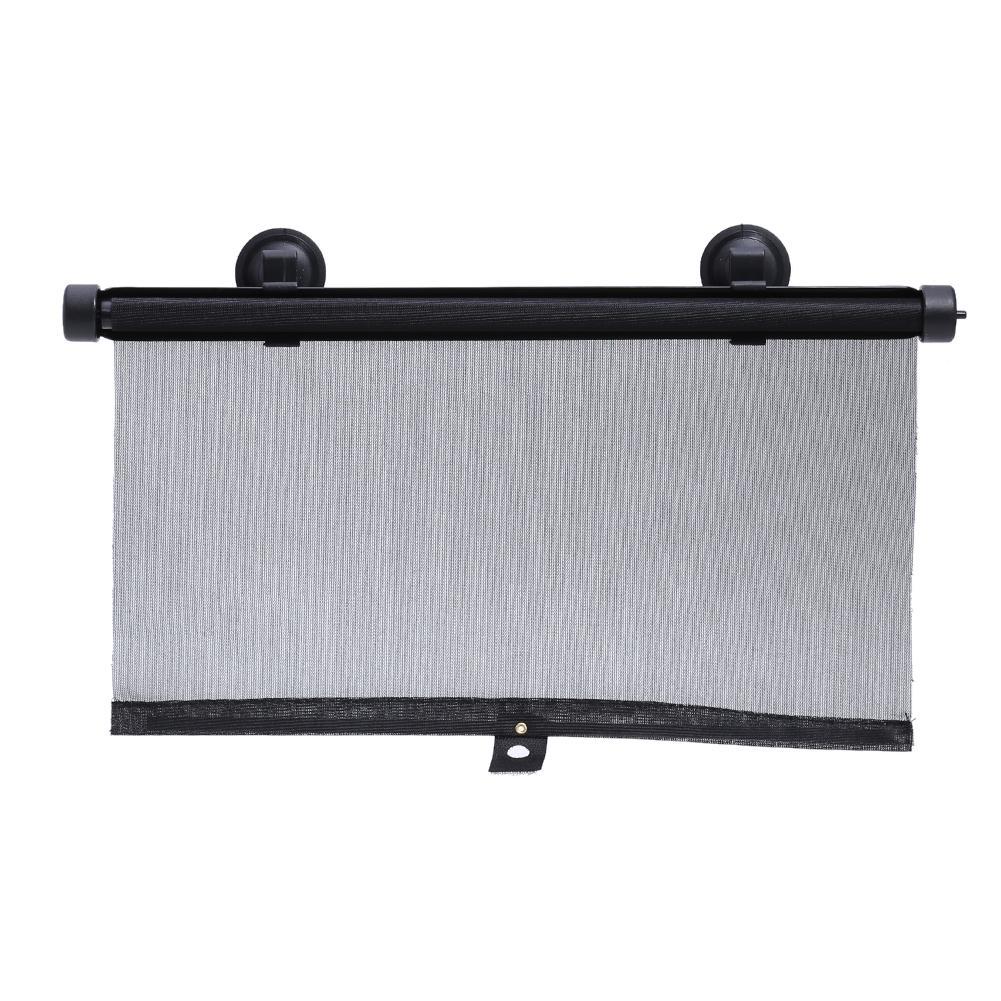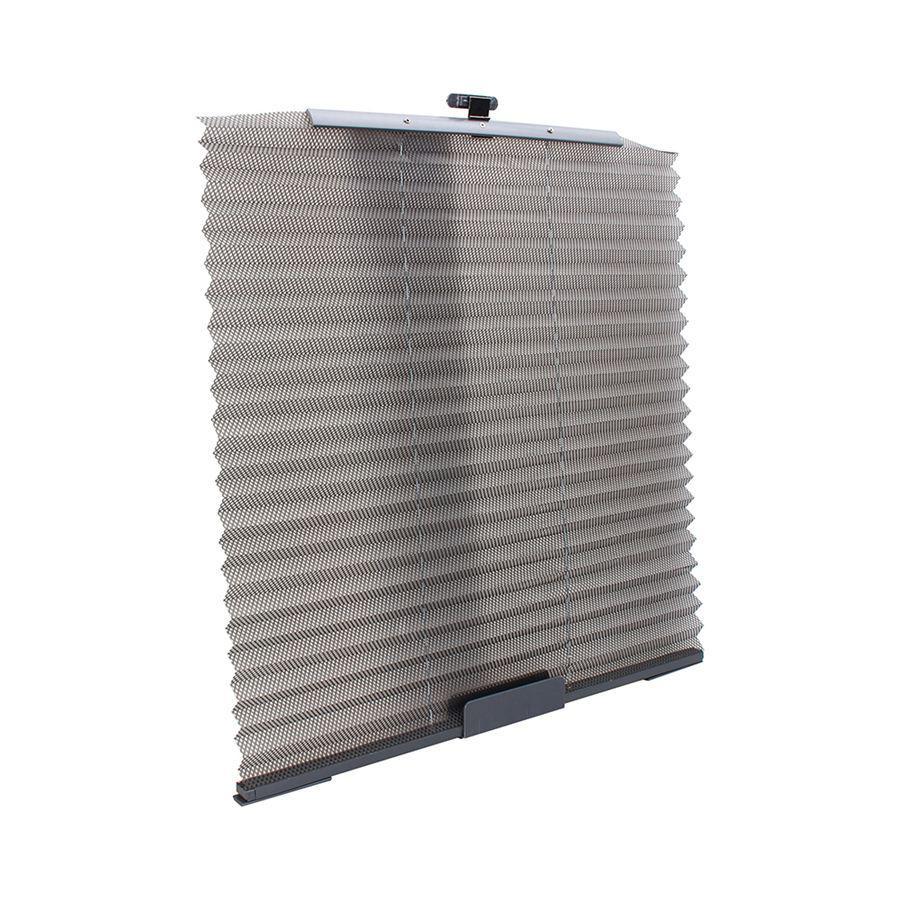The first image is the image on the left, the second image is the image on the right. For the images shown, is this caption "At least one hand shows how to adjust a car window shade with two suction cups at the top and one at the bottom." true? Answer yes or no. No. 